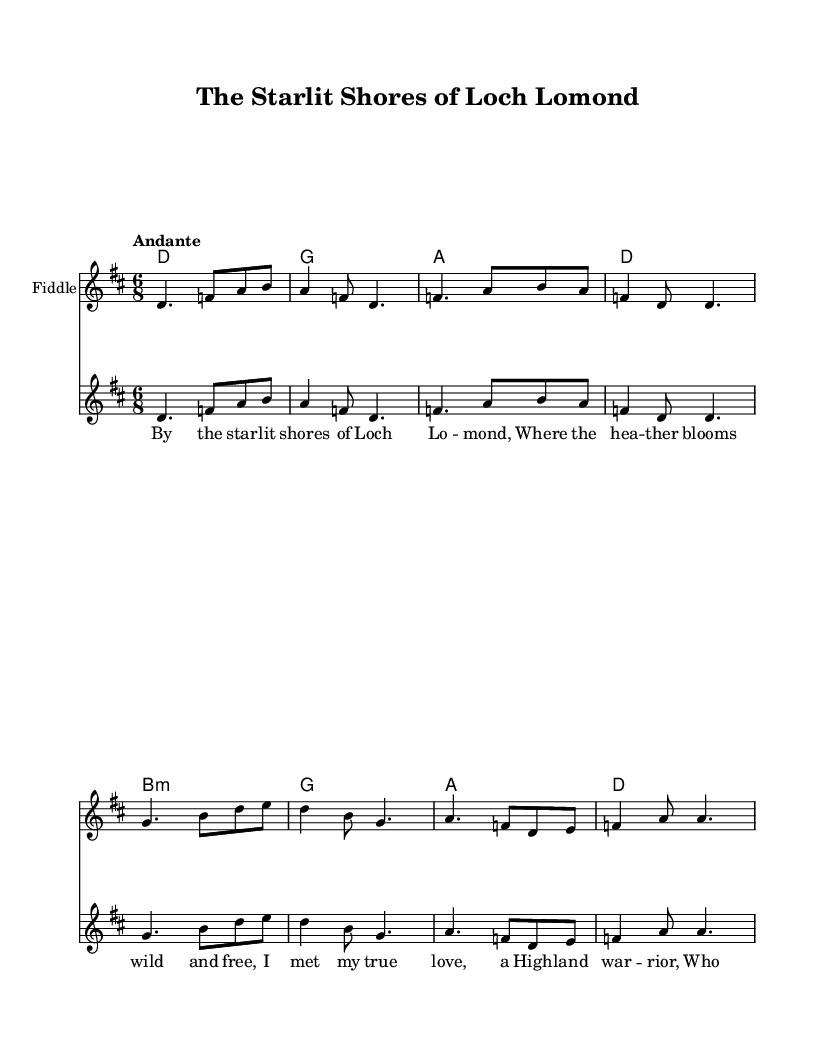What is the key signature of this music? The key signature is D major, which has two sharps: F# and C#. This can be identified at the beginning of the sheet music.
Answer: D major What is the time signature of this piece? The time signature is 6/8, which indicates there are six eighth notes in each measure. This is indicated at the beginning of the score.
Answer: 6/8 What is the tempo marking for this composition? The tempo marking is "Andante," which indicates a moderate walking pace for the music. This is noted in the tempo section of the score.
Answer: Andante How many measures are in the melody section? The melody section has a total of 8 measures, which can be counted by identifying the bars in the melody notation.
Answer: 8 What emotional theme is reflected in the lyrics of the ballad? The lyrics convey themes of love and longing, as they recount a romantic meeting by the shore. This is evident from the content of the lyrics presented.
Answer: Love What musical instrument is specified for the melody? The specified instrument for the melody is the Fiddle, as indicated in the staff notation.
Answer: Fiddle Which Scottish location is mentioned in the lyrics? The lyrics mention "Loch Lomond," which is a famous lake in Scotland and forms part of the song's romantic narrative. This is stated in the first line of the lyrics.
Answer: Loch Lomond 